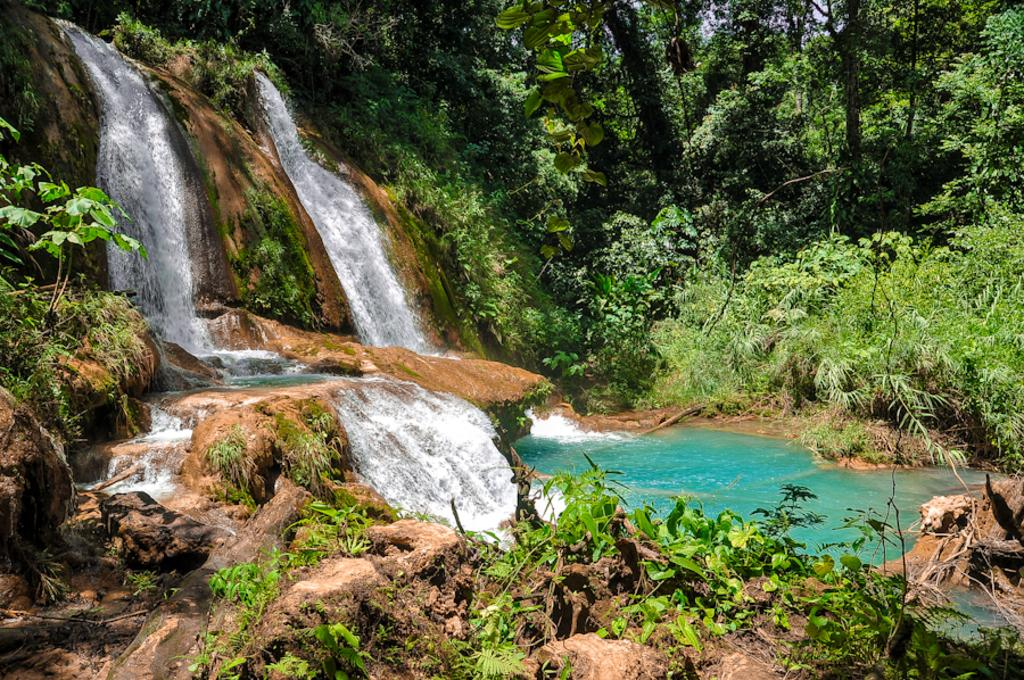What natural feature is present in the image? There is a waterfall in the image. What type of geological formation can be seen in the image? There are rocks in the image. What type of vegetation is present in the image? There is grass in the image. What type of plant life is present in the image? There are trees in the image. What type of trip can be seen being taken in the image? There is no trip present in the image; it features a waterfall, rocks, grass, and trees. What type of bomb can be seen in the image? There is no bomb present in the image; it features a waterfall, rocks, grass, and trees. 